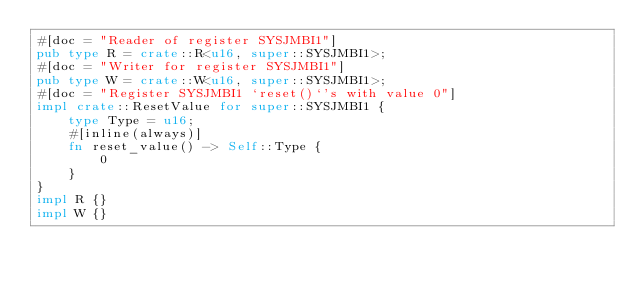<code> <loc_0><loc_0><loc_500><loc_500><_Rust_>#[doc = "Reader of register SYSJMBI1"]
pub type R = crate::R<u16, super::SYSJMBI1>;
#[doc = "Writer for register SYSJMBI1"]
pub type W = crate::W<u16, super::SYSJMBI1>;
#[doc = "Register SYSJMBI1 `reset()`'s with value 0"]
impl crate::ResetValue for super::SYSJMBI1 {
    type Type = u16;
    #[inline(always)]
    fn reset_value() -> Self::Type {
        0
    }
}
impl R {}
impl W {}
</code> 